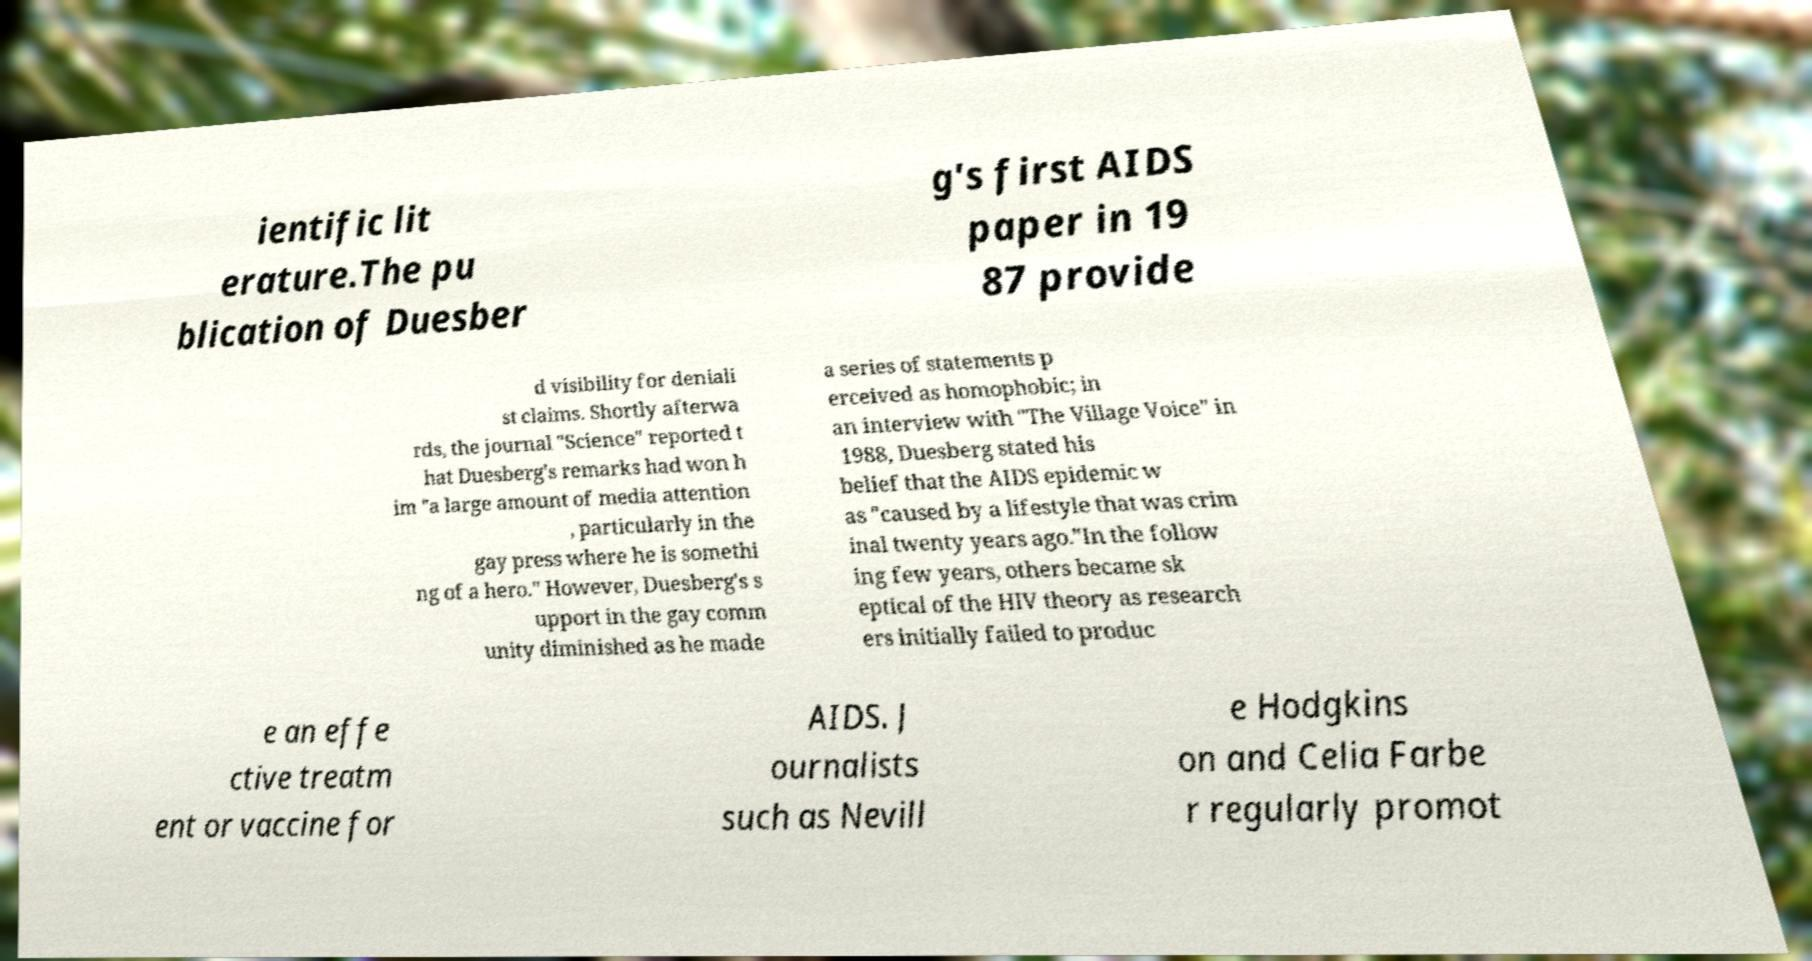Can you accurately transcribe the text from the provided image for me? ientific lit erature.The pu blication of Duesber g's first AIDS paper in 19 87 provide d visibility for deniali st claims. Shortly afterwa rds, the journal "Science" reported t hat Duesberg's remarks had won h im "a large amount of media attention , particularly in the gay press where he is somethi ng of a hero." However, Duesberg's s upport in the gay comm unity diminished as he made a series of statements p erceived as homophobic; in an interview with "The Village Voice" in 1988, Duesberg stated his belief that the AIDS epidemic w as "caused by a lifestyle that was crim inal twenty years ago."In the follow ing few years, others became sk eptical of the HIV theory as research ers initially failed to produc e an effe ctive treatm ent or vaccine for AIDS. J ournalists such as Nevill e Hodgkins on and Celia Farbe r regularly promot 